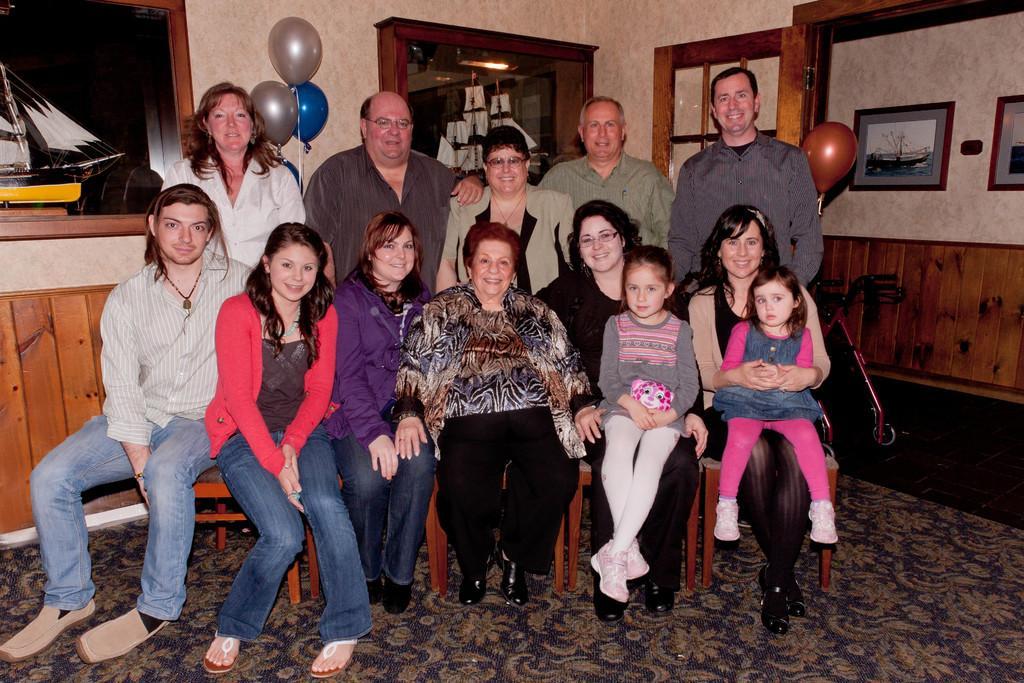Can you describe this image briefly? In this image I can see people present in a room. There are balloons and photo frames are present on the walls. 